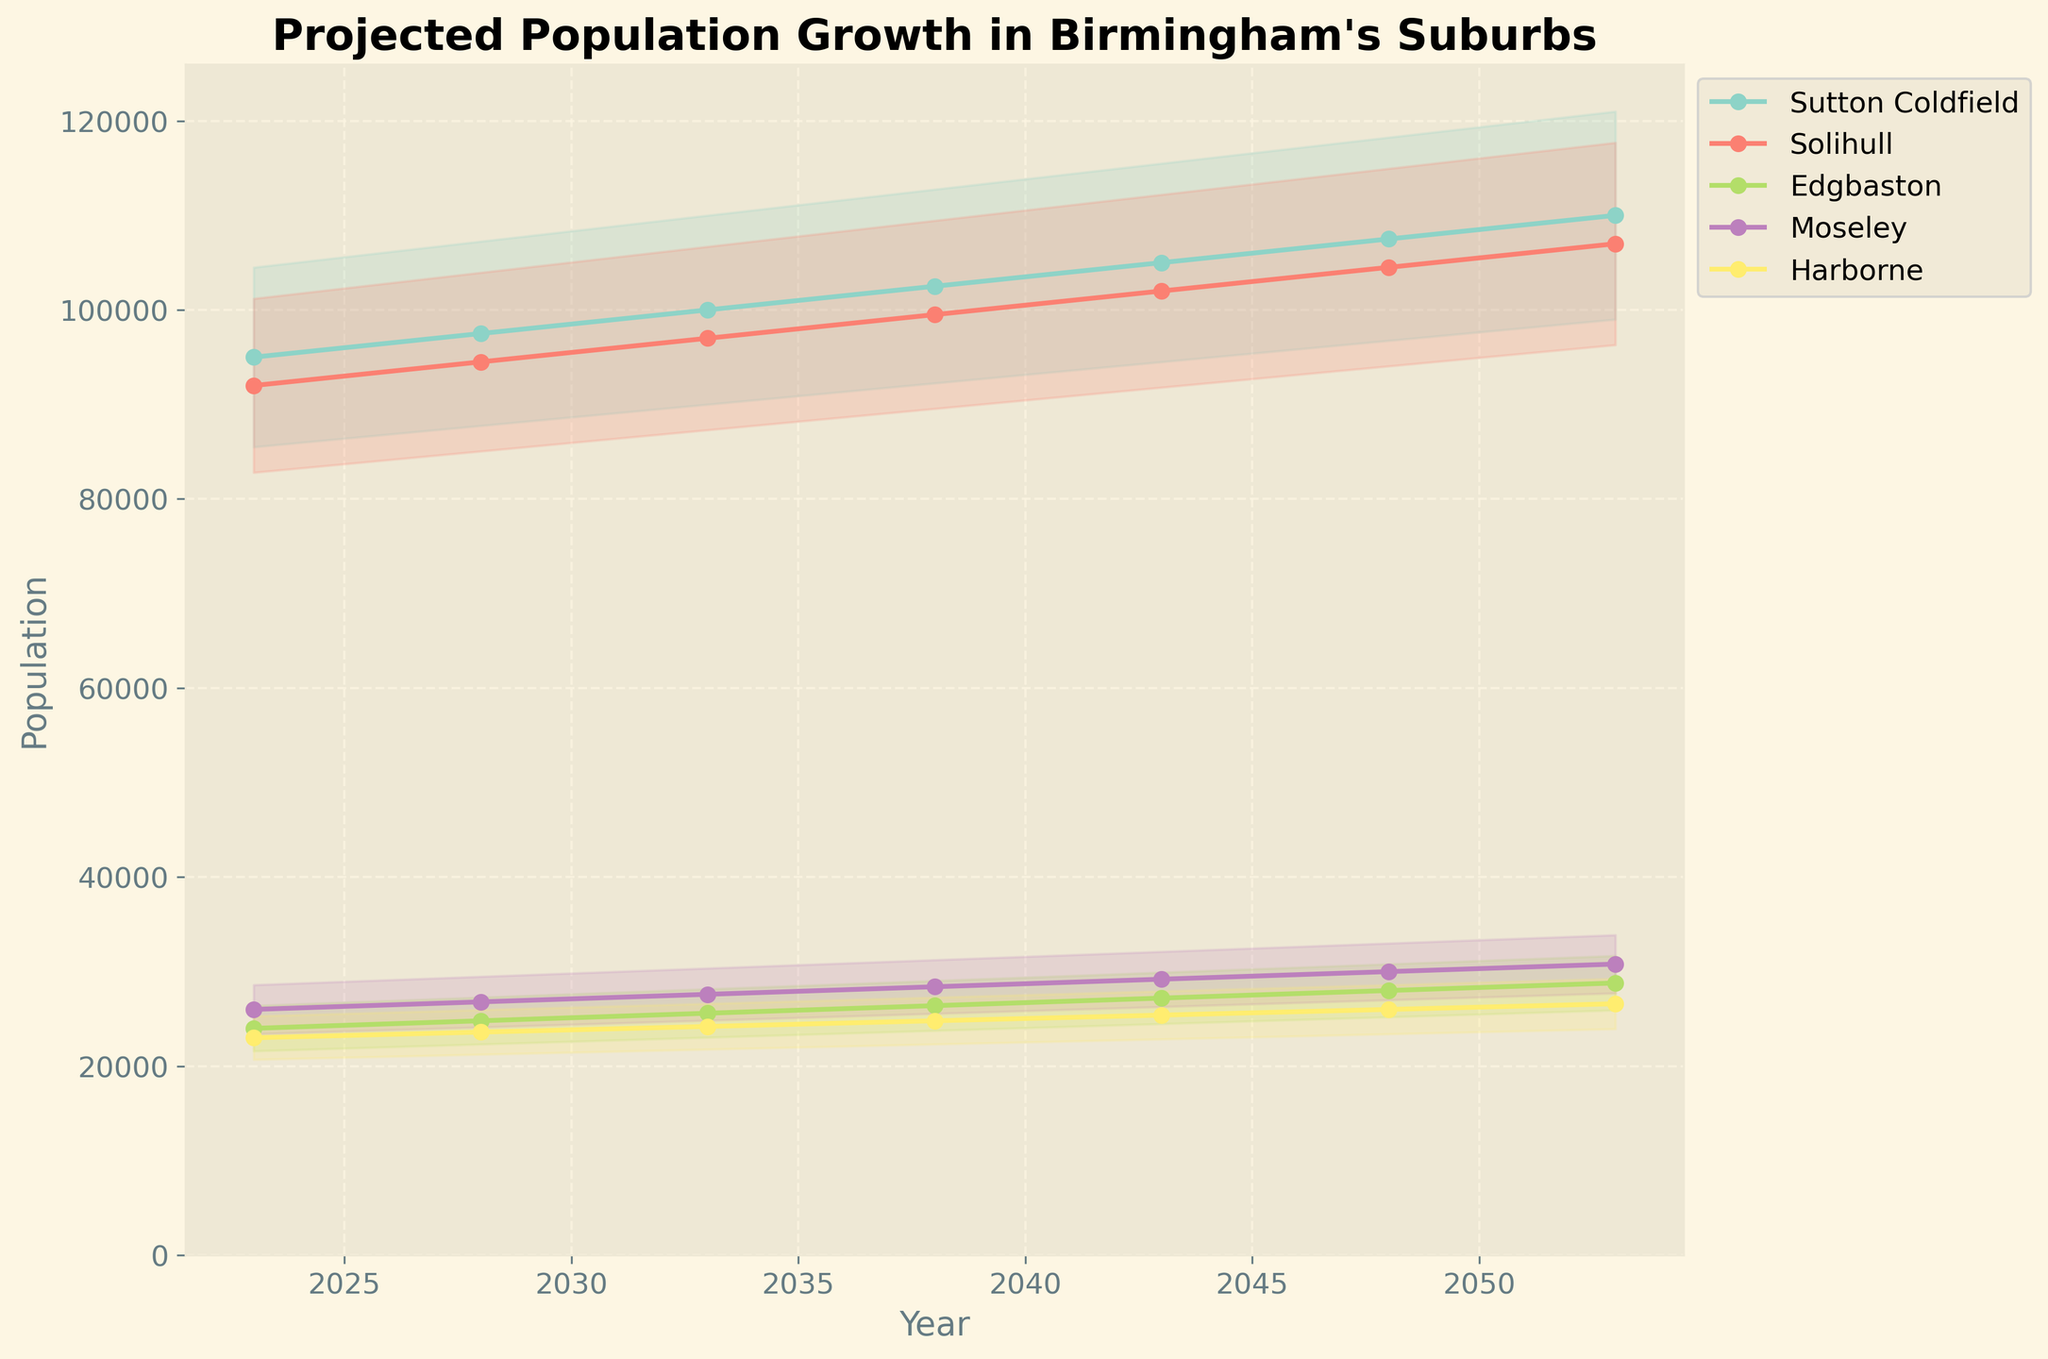What is the title of the figure? The title of the figure is usually displayed at the top of the chart. By looking at the top of the chart, we can see the title "Projected Population Growth in Birmingham's Suburbs".
Answer: Projected Population Growth in Birmingham's Suburbs What is the population of Harborne projected to be in 2043? To find the population of Harborne in 2043, locate the year 2043 on the x-axis and then find the corresponding value for Harborne.
Answer: 25,400 Which suburb has the highest projected population in 2028? By looking at the values for each suburb in the year 2028 on the x-axis, compare their heights. Sutton Coldfield has the highest value.
Answer: Sutton Coldfield Is Solihull’s population expected to grow more or less than Edgbaston’s from 2023 to 2053? To determine growth, calculate the difference between the 2023 and 2053 values for both suburbs. For Solihull, subtract 92,000 from 107,000. For Edgbaston, subtract 24,000 from 28,800. Compare the two results.
Answer: More How much is Moseley’s population projected to increase between 2023 and 2053? Find the population of Moseley in 2023 and 2053 on the y-axis, which are 26,000 and 30,800 respectively. Subtract the 2023 value from the 2053 value.
Answer: 4,800 In what year is Sutton Coldfield projected to reach a population of 100,000? Identify the year when Sutton Coldfield’s population line hits 100,000 on the y-axis.
Answer: 2033 Which suburb shows the least variation in the projections over the years? Compare the width of the fan effects for each suburb. The suburb with the narrowest fan effect line across the years has the least variation.
Answer: Edgbaston What is the population difference between Solihull and Harborne projected to be in 2048? To determine the difference, find the projected population for both suburbs in 2048 and subtract Harborne’s value from Solihull’s value.
Answer: 78,500 